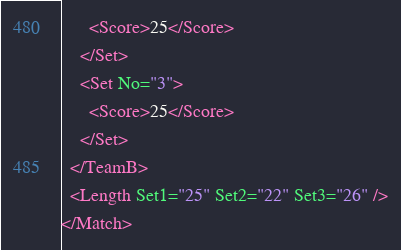Convert code to text. <code><loc_0><loc_0><loc_500><loc_500><_XML_>      <Score>25</Score>
    </Set>
    <Set No="3">
      <Score>25</Score>
    </Set>
  </TeamB>
  <Length Set1="25" Set2="22" Set3="26" />
</Match></code> 